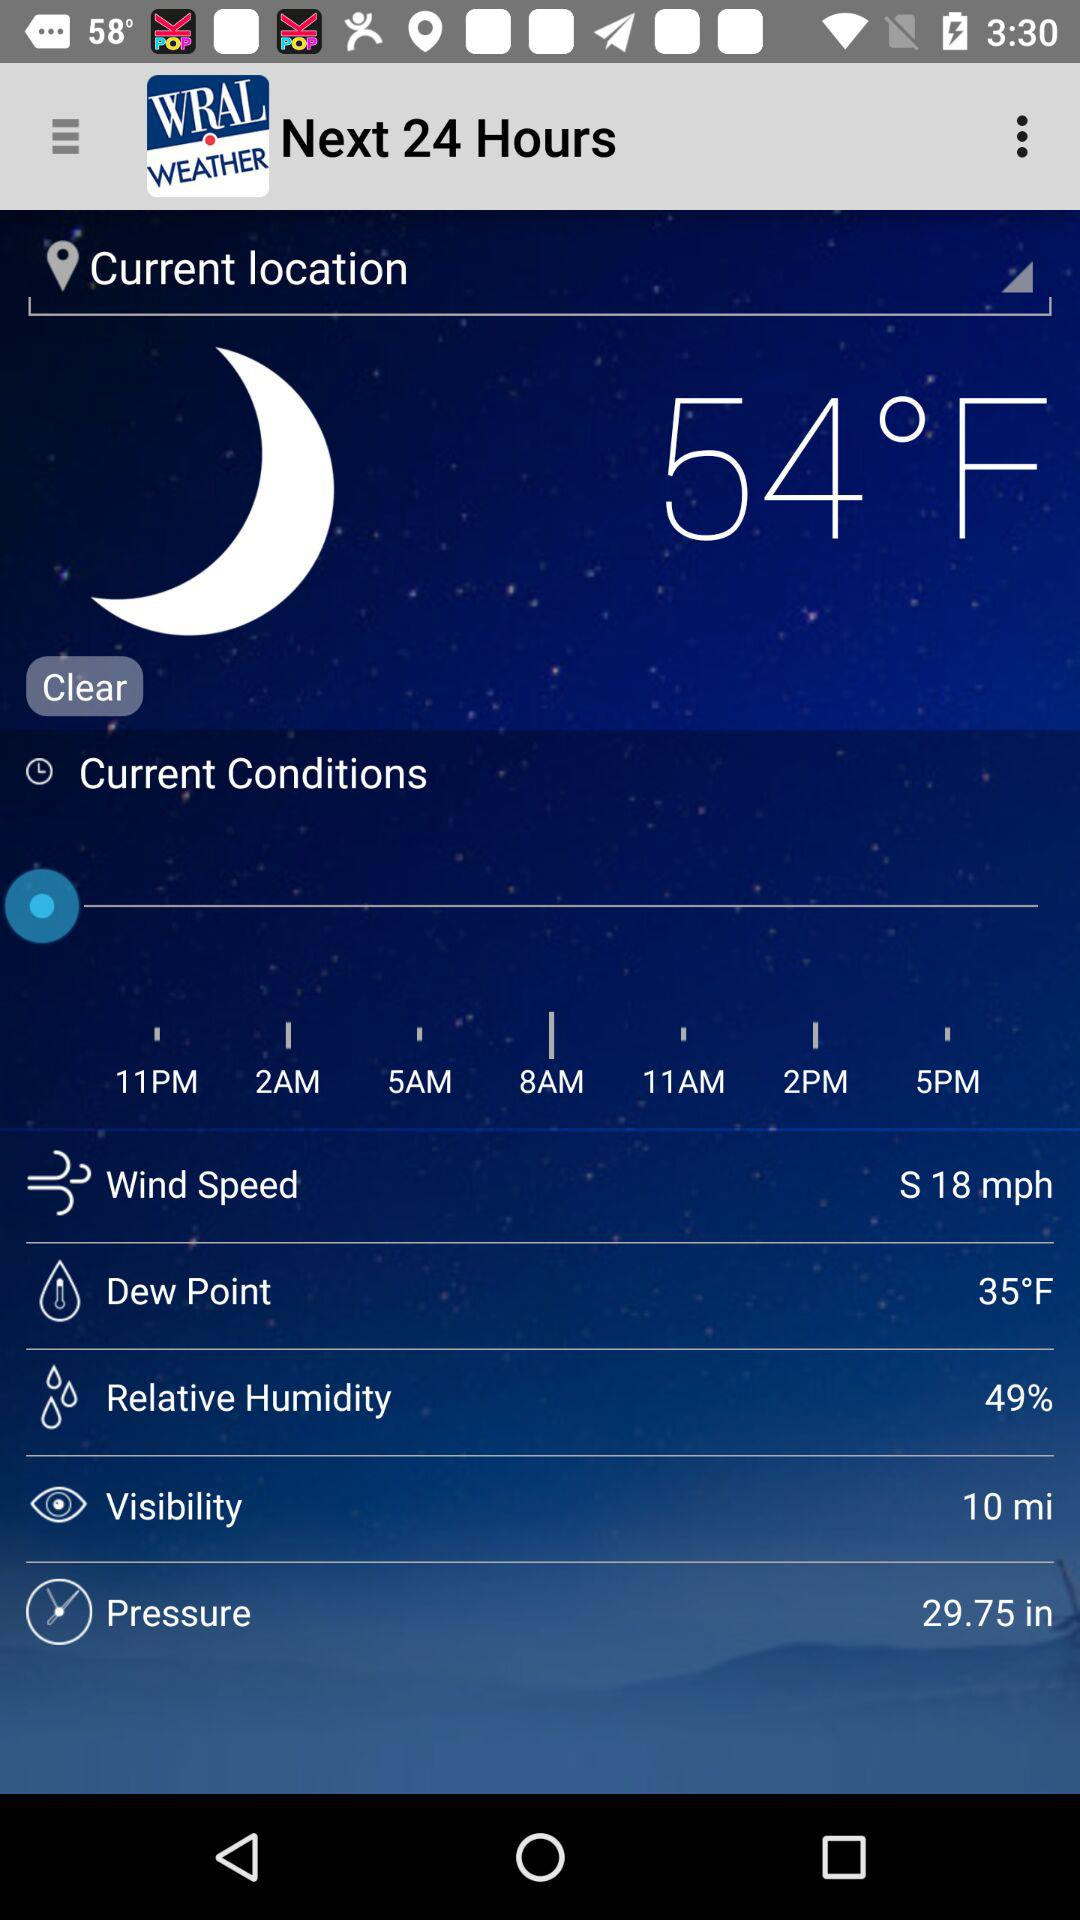What is the relative humidity percentage? The relative humidity is 49%. 